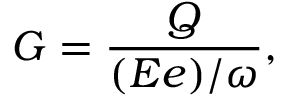Convert formula to latex. <formula><loc_0><loc_0><loc_500><loc_500>G = \frac { Q } { ( E e ) / \omega } ,</formula> 